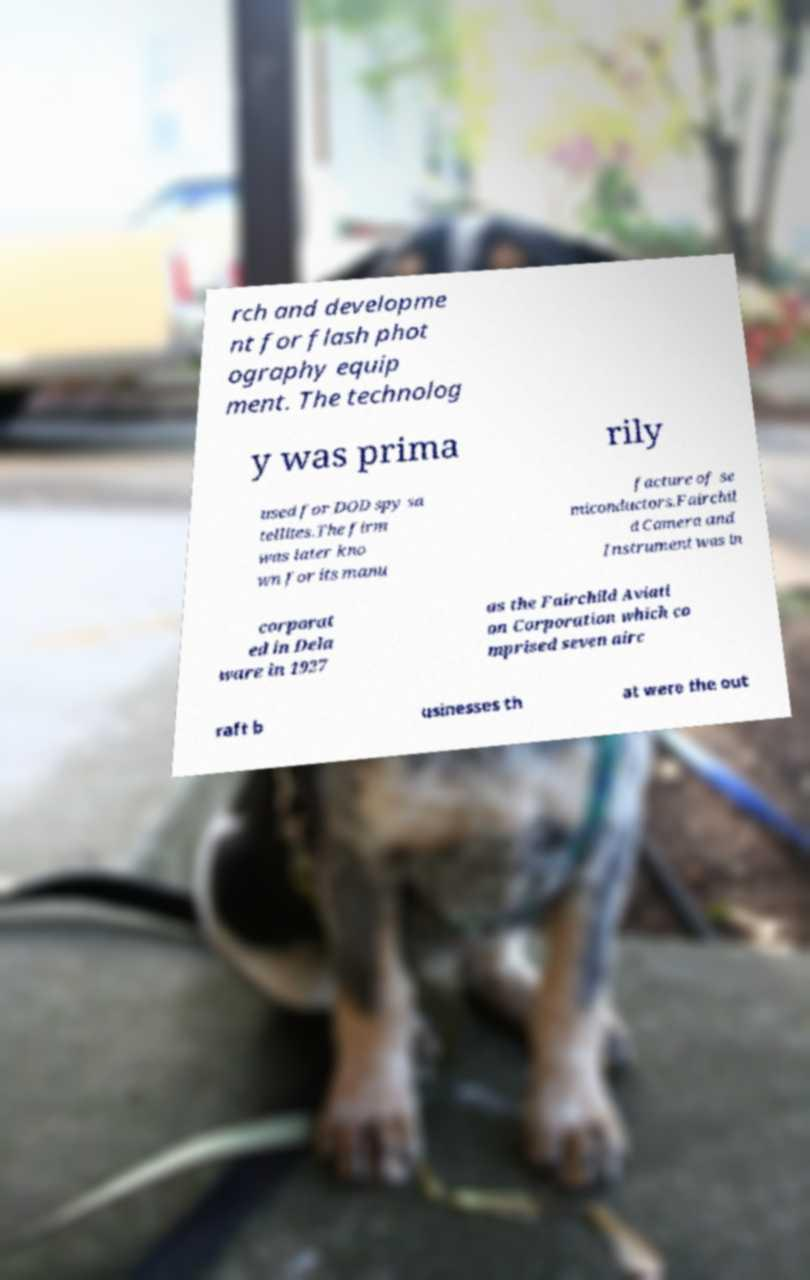Can you read and provide the text displayed in the image?This photo seems to have some interesting text. Can you extract and type it out for me? rch and developme nt for flash phot ography equip ment. The technolog y was prima rily used for DOD spy sa tellites.The firm was later kno wn for its manu facture of se miconductors.Fairchil d Camera and Instrument was in corporat ed in Dela ware in 1927 as the Fairchild Aviati on Corporation which co mprised seven airc raft b usinesses th at were the out 